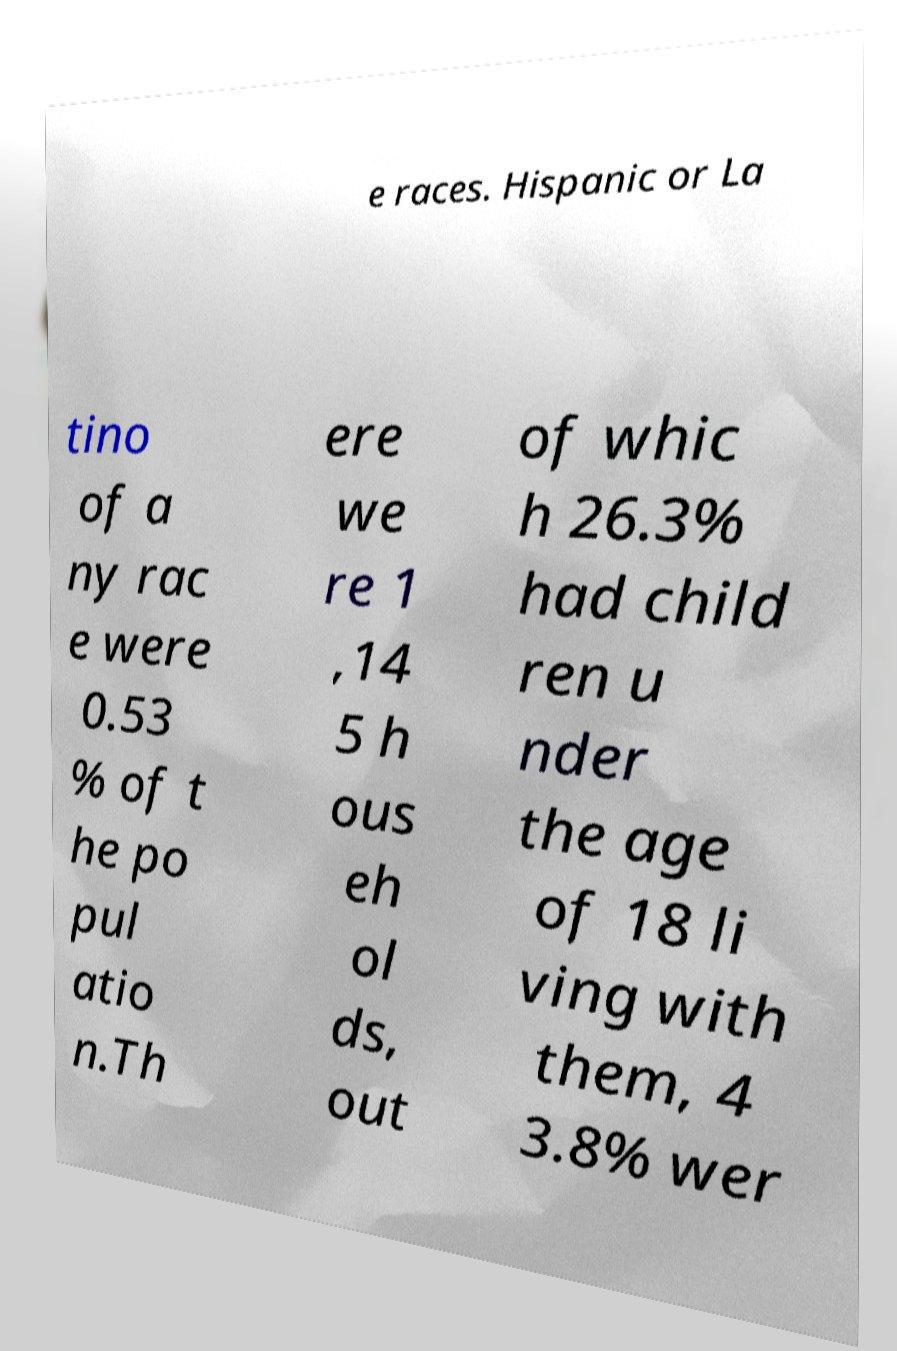There's text embedded in this image that I need extracted. Can you transcribe it verbatim? e races. Hispanic or La tino of a ny rac e were 0.53 % of t he po pul atio n.Th ere we re 1 ,14 5 h ous eh ol ds, out of whic h 26.3% had child ren u nder the age of 18 li ving with them, 4 3.8% wer 